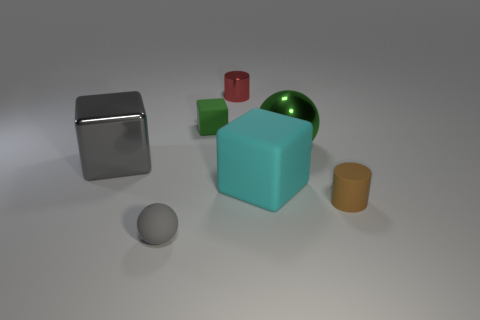There is a tiny matte object that is the same color as the metallic cube; what is its shape?
Offer a very short reply. Sphere. There is a green thing that is the same material as the red thing; what is its shape?
Provide a short and direct response. Sphere. How many small objects are either gray matte balls or shiny cylinders?
Give a very brief answer. 2. There is a object behind the tiny cube; is there a object that is on the left side of it?
Your answer should be compact. Yes. Is there a big matte object?
Ensure brevity in your answer.  Yes. What color is the sphere that is left of the metal object behind the big green sphere?
Your response must be concise. Gray. There is another big thing that is the same shape as the gray rubber thing; what material is it?
Provide a succinct answer. Metal. How many blue matte cylinders are the same size as the green metallic object?
Offer a terse response. 0. There is a cyan object that is made of the same material as the tiny brown cylinder; what is its size?
Your answer should be very brief. Large. How many other things have the same shape as the tiny brown thing?
Offer a very short reply. 1. 